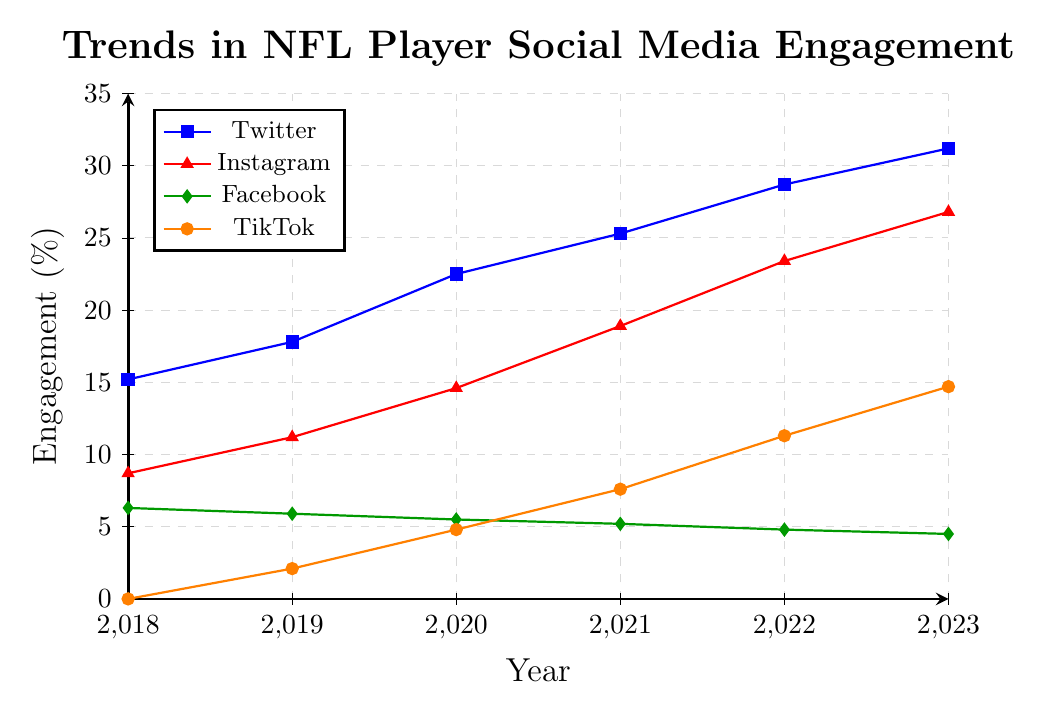Which platform had the highest engagement on character-related topics in 2023? The legend indicates different colors for each platform. The lines represent engagement. The line reaching the highest point in 2023 is blue for Twitter.
Answer: Twitter Which social media platform showed a consistent decline in engagement from 2018 to 2023? By looking at the trends of all four lines, the green line (representing Facebook according to the legend) is the only one that consistently decreased each year.
Answer: Facebook Between 2018 and 2023, which platform saw the largest increase in character engagement? We calculate the difference in engagement between 2023 and 2018 for each platform.
- Twitter: 31.2 - 15.2 = 16
- Instagram: 26.8 - 8.7 = 18.1
- Facebook: 4.5 - 6.3 = -1.8
- TikTok: 14.7 - 0 = 14.7
The largest increase is in Instagram with an increase of 18.1.
Answer: Instagram In which year did TikTok surpass Facebook in character engagement? Observing both the orange (TikTok) and green (Facebook) lines, TikTok surpasses Facebook between 2020 (TikTok: 4.8, Facebook: 5.5) and 2021 (TikTok: 7.6, Facebook: 5.2). Therefore, it happened in 2021.
Answer: 2021 What's the total engagement in 2020 combining all four platforms? Sum the engagement values for all platforms in 2020: 22.5 (Twitter) + 14.6 (Instagram) + 5.5 (Facebook) + 4.8 (TikTok) = 47.4
Answer: 47.4 Which year saw the highest growth in Instagram engagement? Calculate the year-over-year differences:
- 2018-2019: 11.2 - 8.7 = 2.5
- 2019-2020: 14.6 - 11.2 = 3.4
- 2020-2021: 18.9 - 14.6 = 4.3
- 2021-2022: 23.4 - 18.9 = 4.5
- 2022-2023: 26.8 - 23.4 = 3.4
The highest growth is from 2021 to 2022 with an increase of 4.5.
Answer: 2021-2022 How does the engagement trend for Facebook in 2019 compare to TikTok in 2021? First, identify values on the graph: Facebook in 2019 (green) is 5.9 and TikTok in 2021 (orange) is 7.6. TikTok in 2021 has higher engagement than Facebook in 2019.
Answer: TikTok in 2021 is higher Which two platforms' engagement levels are closest to each other in 2020? Checking values in 2020: Twitter (22.5), Instagram (14.6), Facebook (5.5), TikTok (4.8). The engagement for Facebook and TikTok are closest: 5.5 and 4.8 respectively.
Answer: Facebook and TikTok 